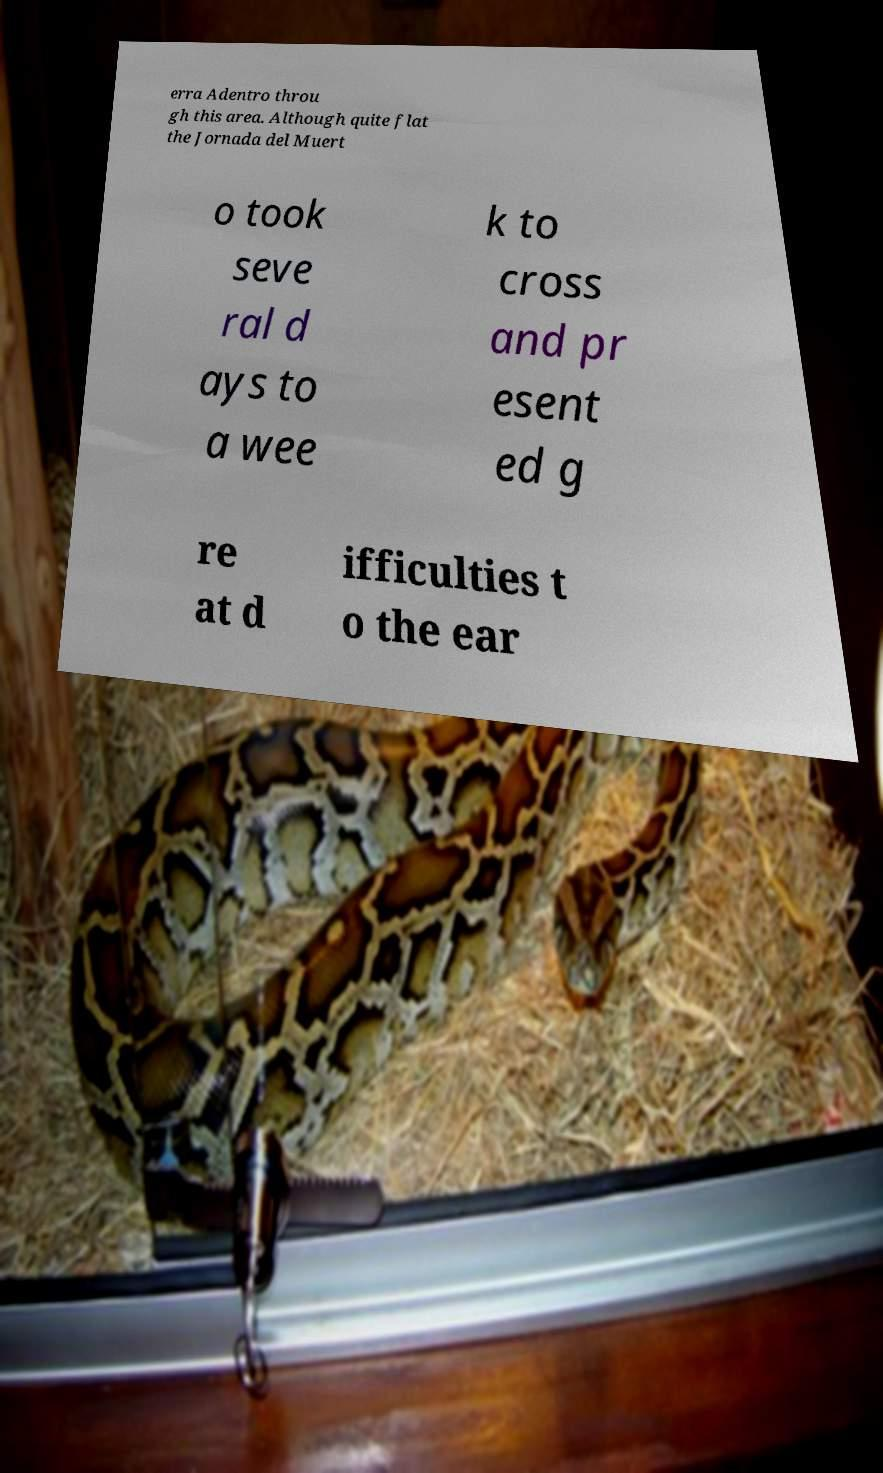There's text embedded in this image that I need extracted. Can you transcribe it verbatim? erra Adentro throu gh this area. Although quite flat the Jornada del Muert o took seve ral d ays to a wee k to cross and pr esent ed g re at d ifficulties t o the ear 